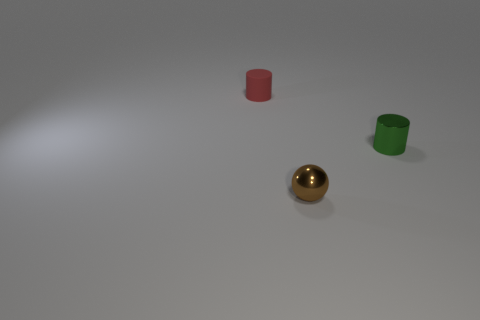Are there any other things that are the same shape as the tiny brown object?
Your answer should be very brief. No. How many metal objects are cyan balls or tiny brown spheres?
Your answer should be compact. 1. What number of metallic cylinders are in front of the cylinder on the right side of the matte cylinder that is behind the green object?
Provide a succinct answer. 0. What number of tiny cylinders have the same color as the small shiny ball?
Your response must be concise. 0. There is a cylinder to the left of the green cylinder; does it have the same size as the brown metallic sphere?
Provide a succinct answer. Yes. What color is the tiny thing that is on the left side of the small green metal thing and to the right of the rubber object?
Provide a succinct answer. Brown. What number of objects are big gray objects or objects that are on the right side of the tiny red rubber object?
Your answer should be very brief. 2. The small red object that is behind the thing in front of the small cylinder that is in front of the small red rubber object is made of what material?
Offer a very short reply. Rubber. Is there anything else that is made of the same material as the red object?
Your response must be concise. No. There is a cylinder that is on the right side of the rubber cylinder; is its color the same as the small matte cylinder?
Make the answer very short. No. 